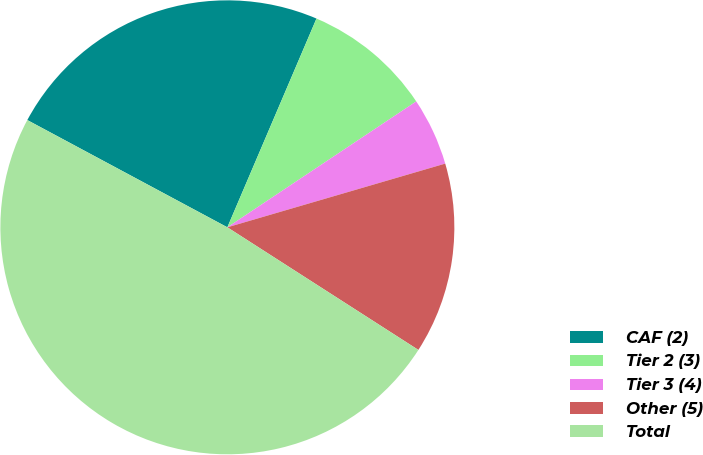<chart> <loc_0><loc_0><loc_500><loc_500><pie_chart><fcel>CAF (2)<fcel>Tier 2 (3)<fcel>Tier 3 (4)<fcel>Other (5)<fcel>Total<nl><fcel>23.59%<fcel>9.22%<fcel>4.83%<fcel>13.61%<fcel>48.75%<nl></chart> 